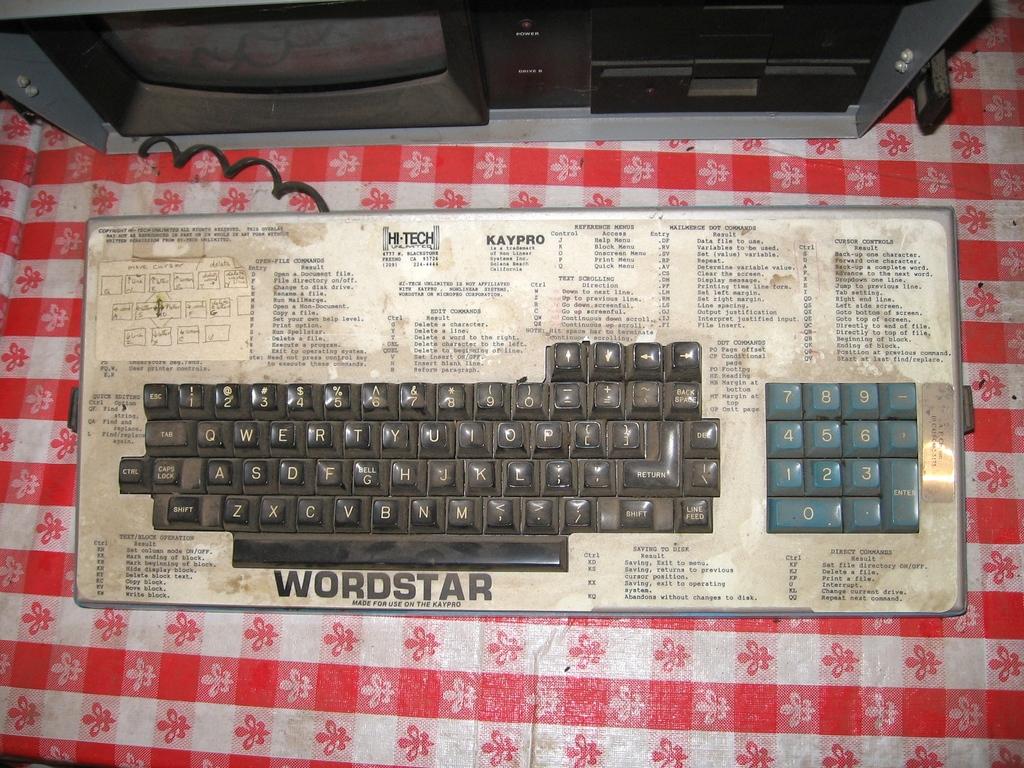What kind of keyboard is this?
Ensure brevity in your answer.  Wordstar. What is written at the top?
Your response must be concise. Hi-tech. 